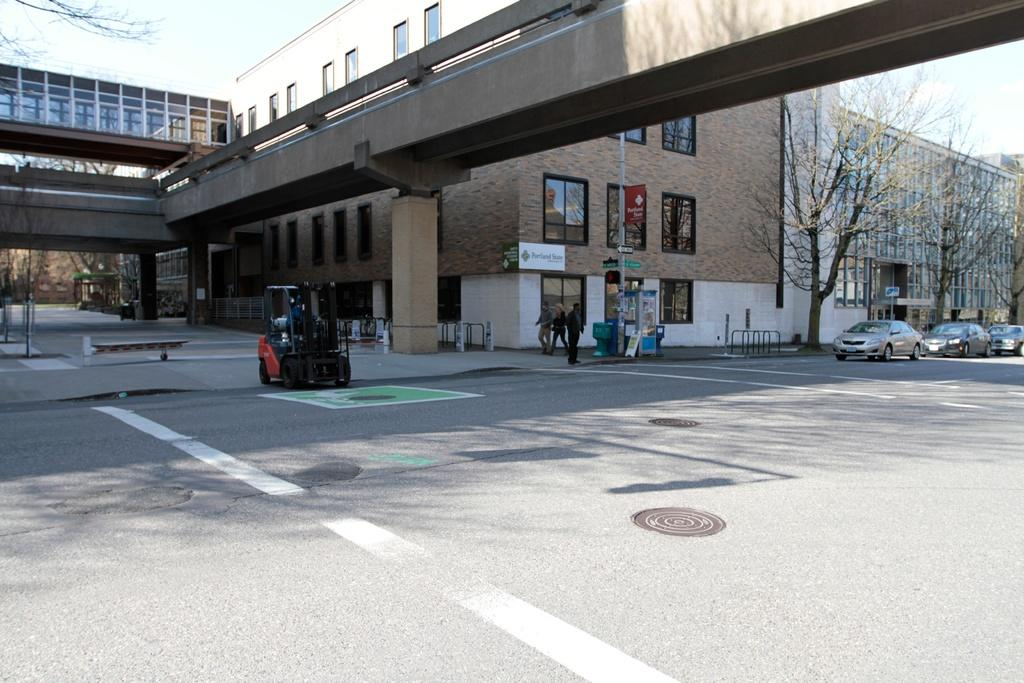What is the main feature of the image? There is a road in the image. What can be seen around the road? There are buildings around the road. What type of natural elements are present in the image? There are trees in the image. What else can be seen on the road? There are vehicles in the image. Are there any living beings in the image? Yes, there are people in the image. Where is the zoo located in the image? There is no zoo present in the image. What type of parent is depicted in the image? There is no parent depicted in the image. 